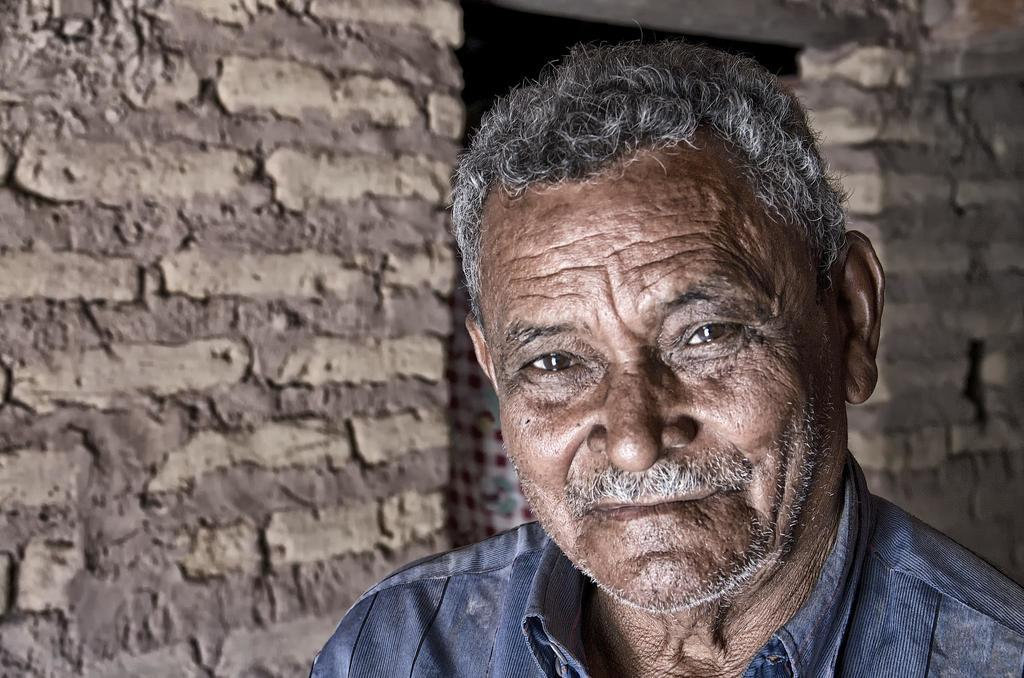Who is present in the image? There is a man in the image. What is behind the man in the image? There is a wall behind the man in the image. What type of jelly is being used as a punishment in the image? There is no jelly or punishment present in the image; it only features a man and a wall. Is there a volleyball game happening in the image? There is no volleyball game or any reference to sports in the image. 